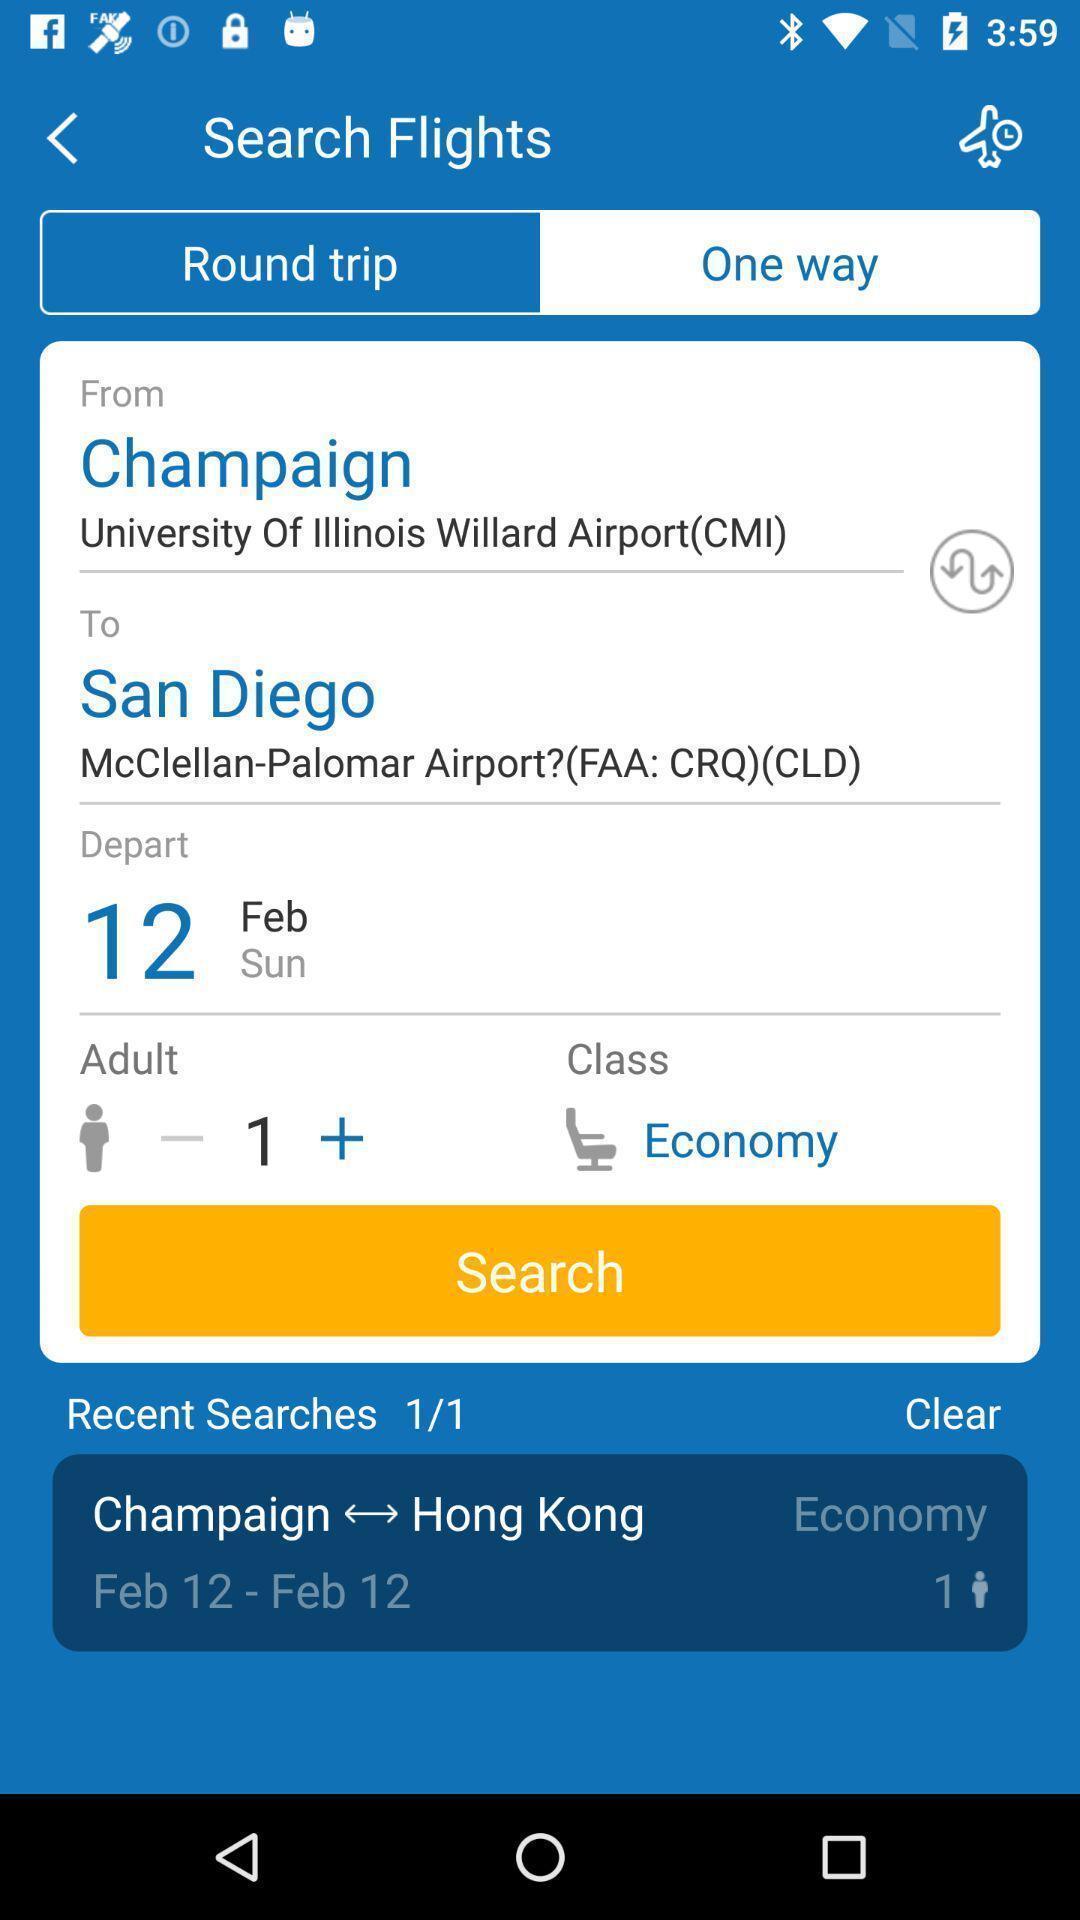Summarize the main components in this picture. Search page in a flight booking app. 